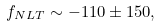<formula> <loc_0><loc_0><loc_500><loc_500>f _ { N L T } \sim - 1 1 0 \pm 1 5 0 ,</formula> 